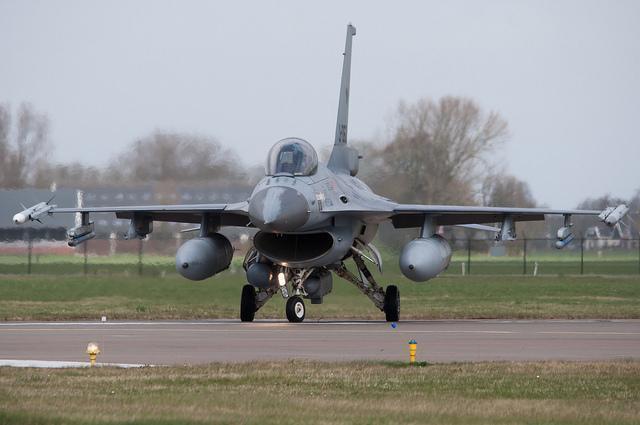How many airplanes are there?
Give a very brief answer. 1. 